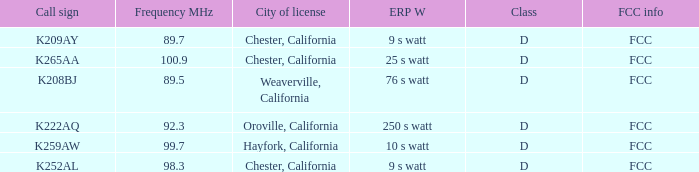Name the call sign with frequency of 89.5 K208BJ. 